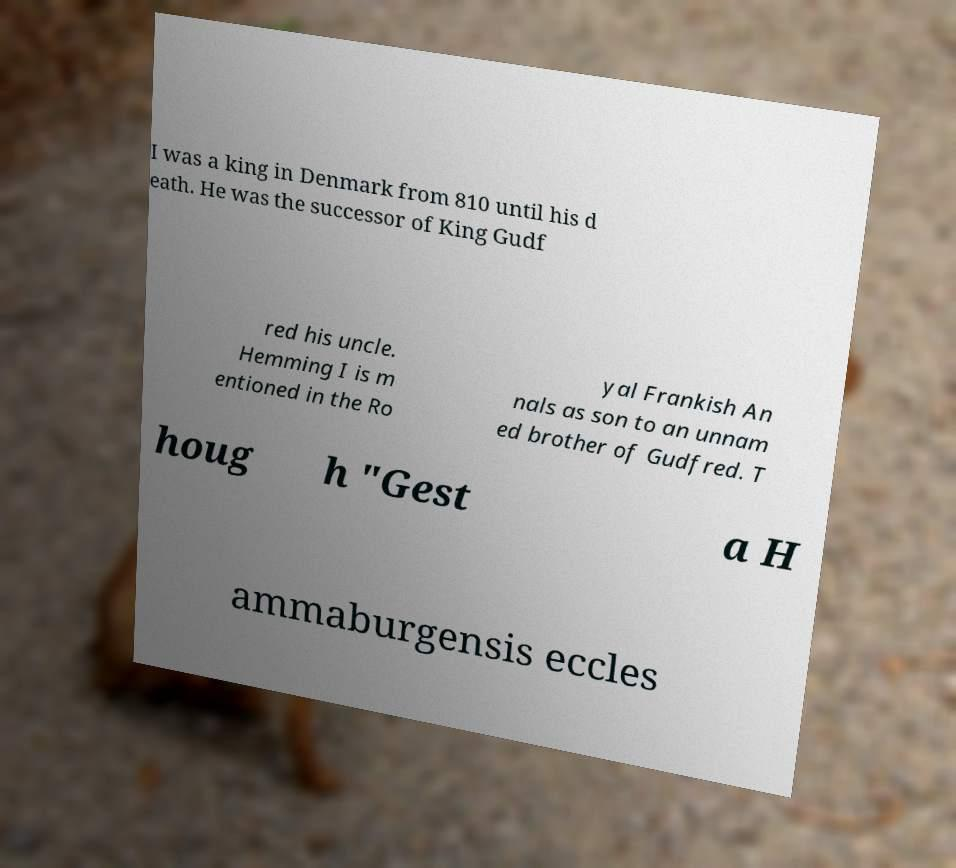Could you assist in decoding the text presented in this image and type it out clearly? I was a king in Denmark from 810 until his d eath. He was the successor of King Gudf red his uncle. Hemming I is m entioned in the Ro yal Frankish An nals as son to an unnam ed brother of Gudfred. T houg h "Gest a H ammaburgensis eccles 